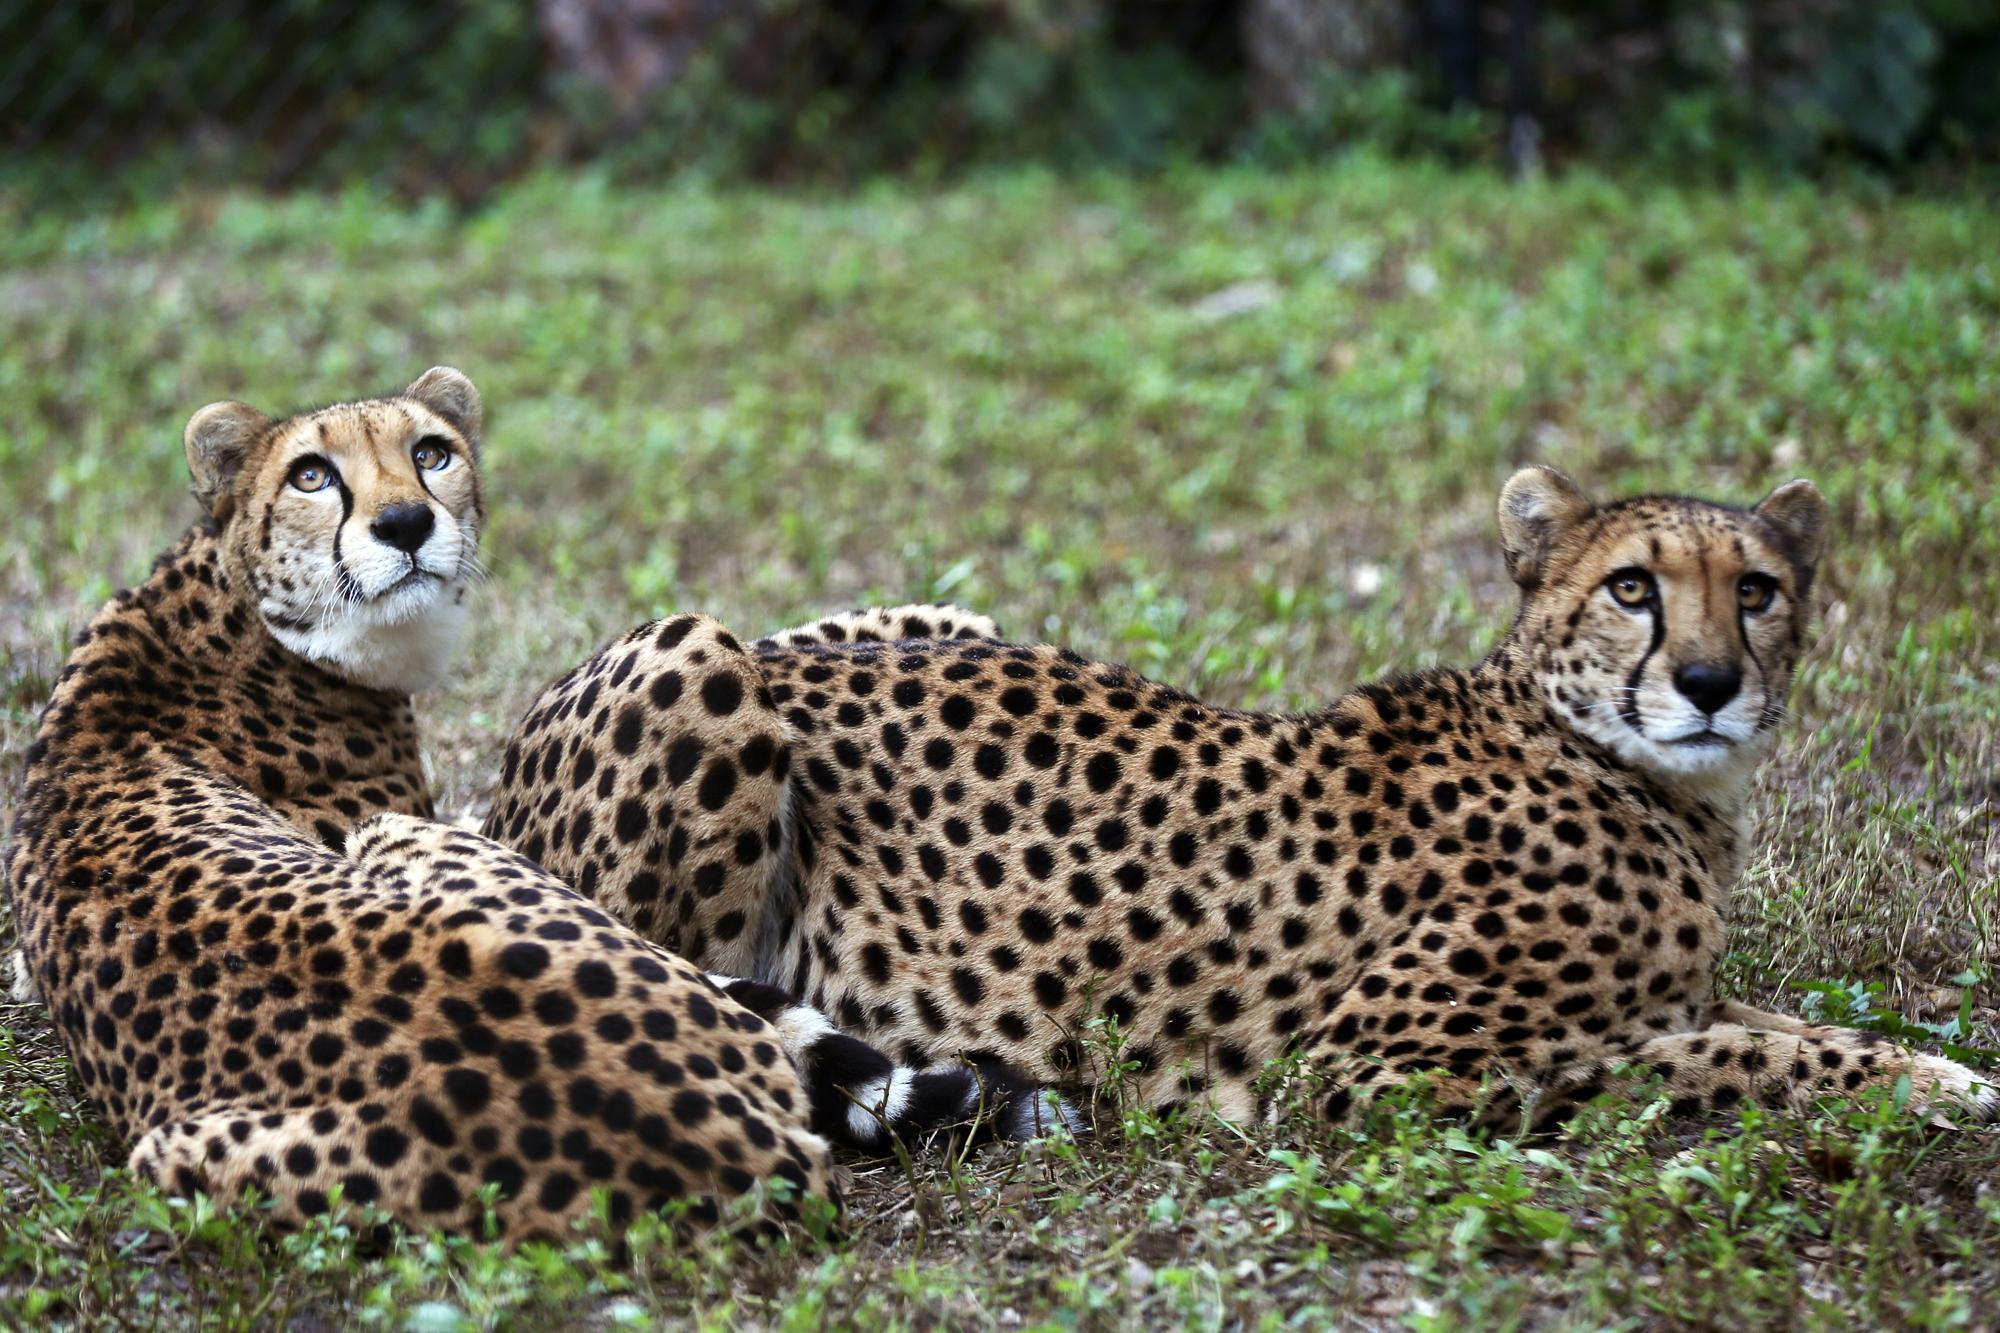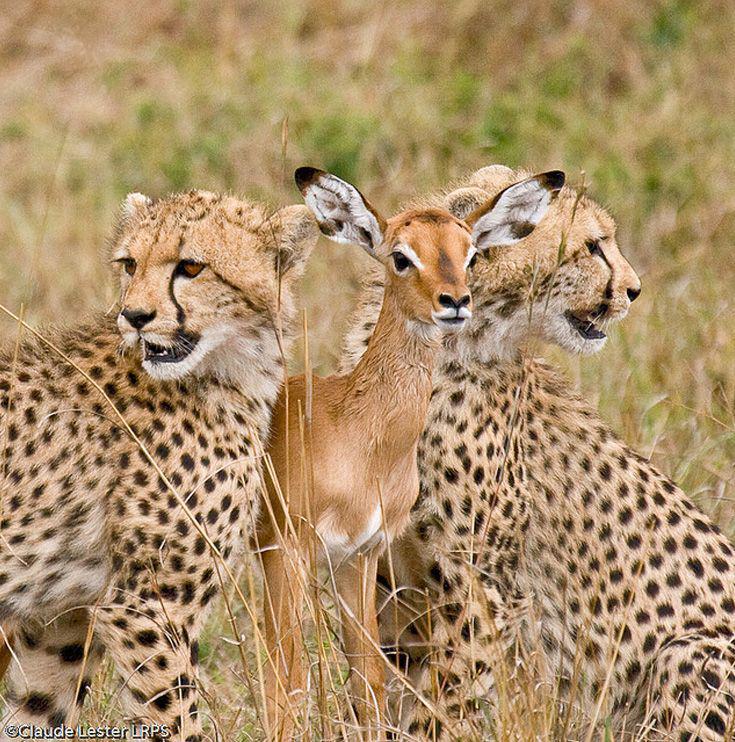The first image is the image on the left, the second image is the image on the right. For the images shown, is this caption "The left image contains a cheetah licking another cheetah." true? Answer yes or no. No. The first image is the image on the left, the second image is the image on the right. Considering the images on both sides, is "An image shows one spotted wild cat licking the face of another wild cat." valid? Answer yes or no. No. 